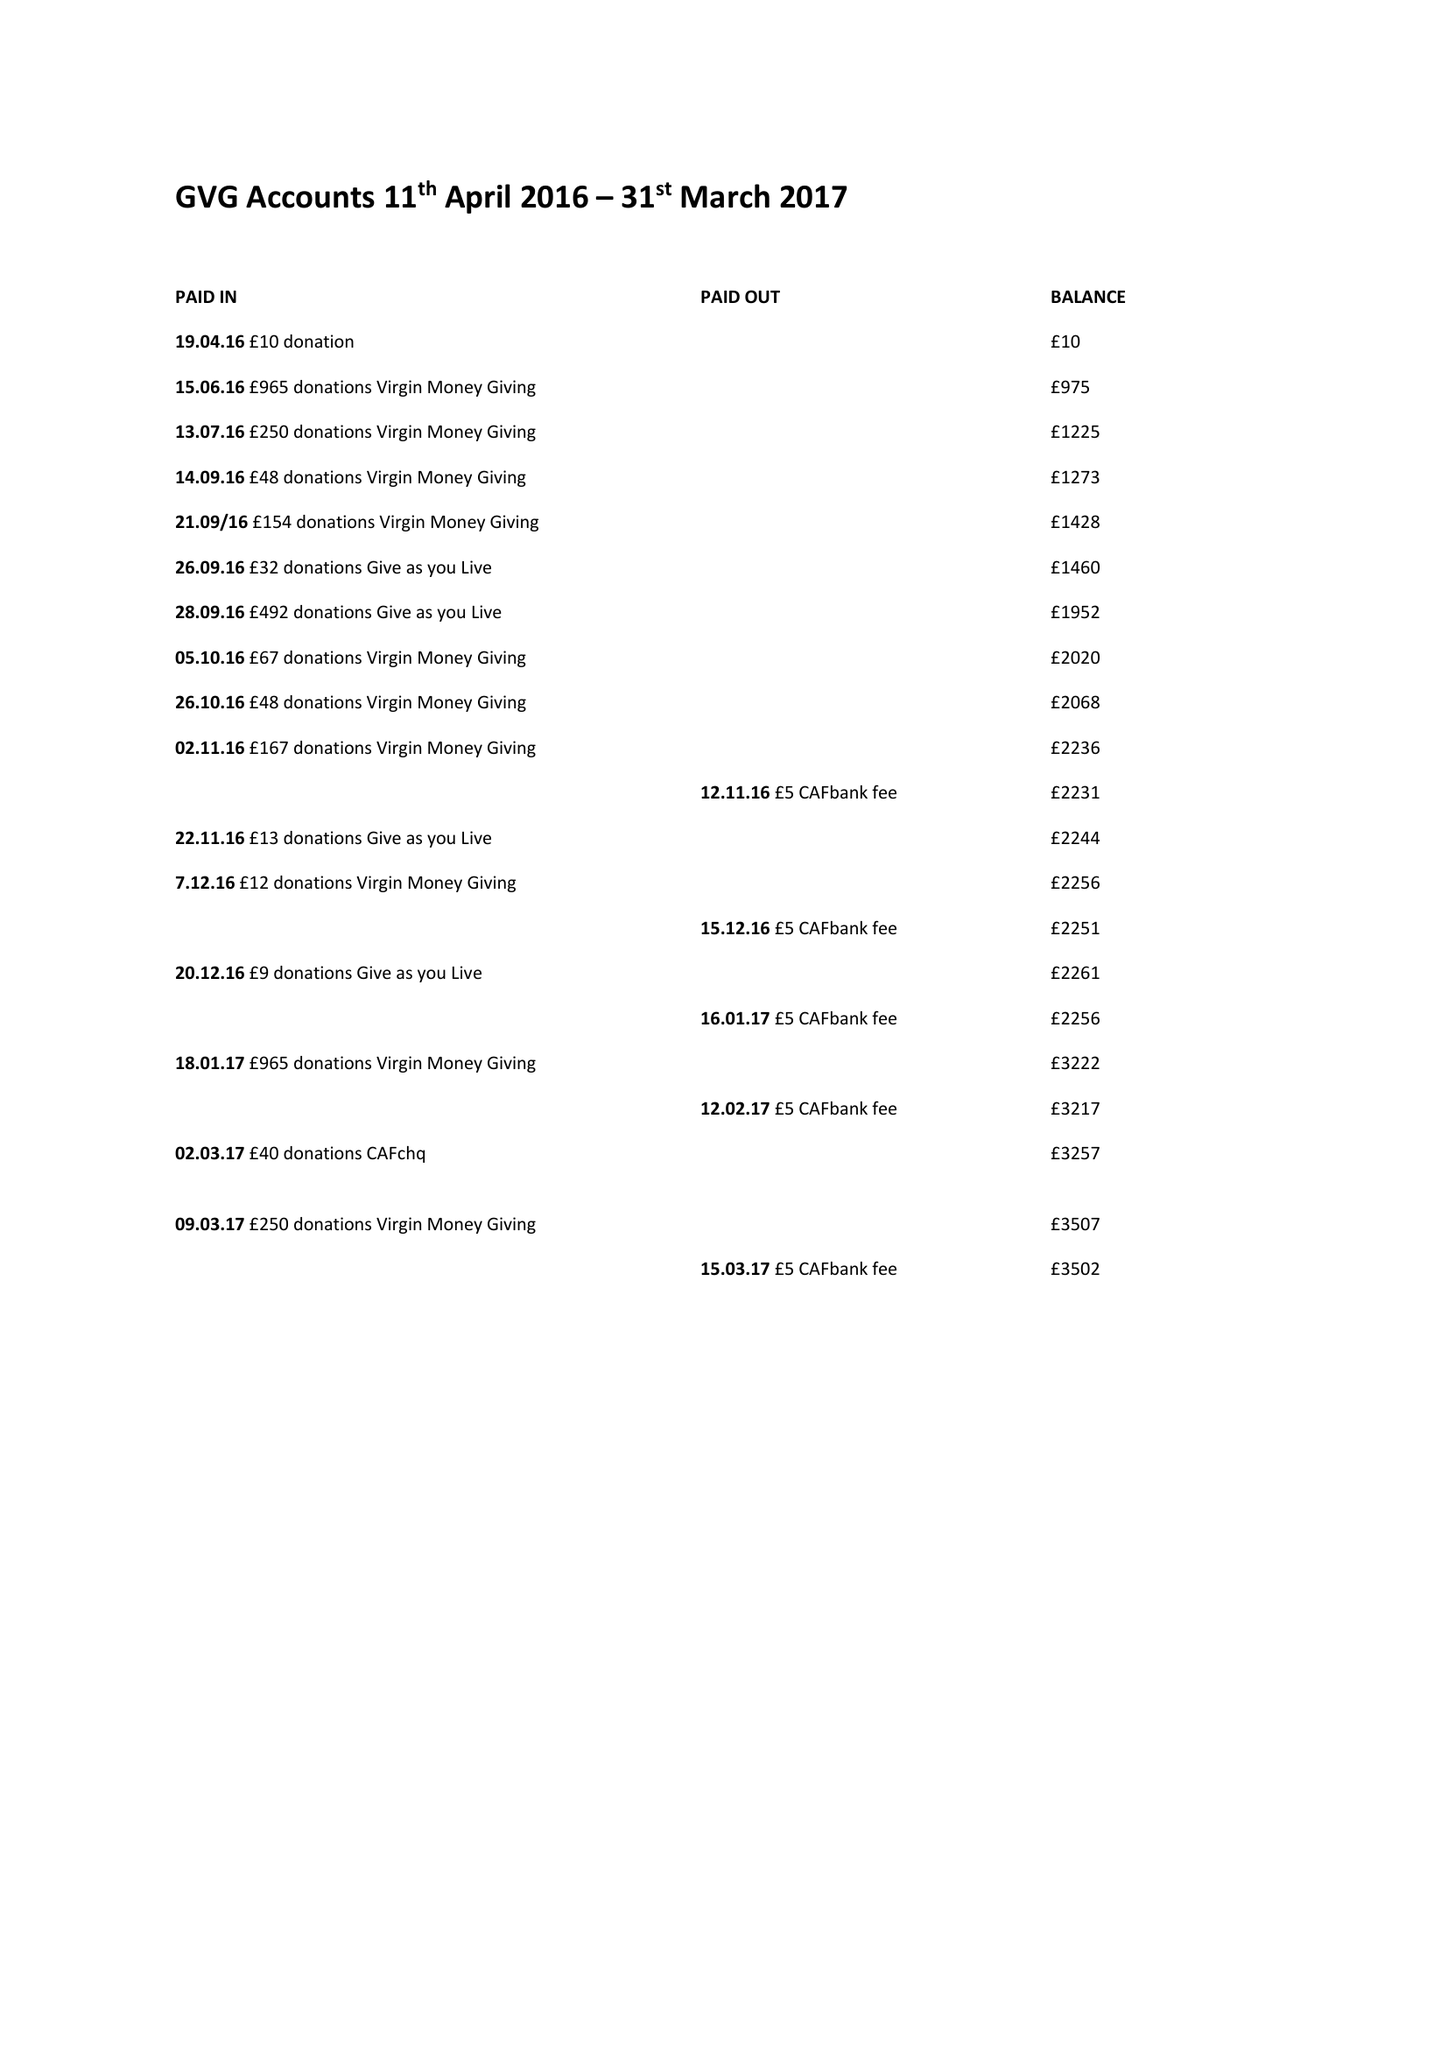What is the value for the address__post_town?
Answer the question using a single word or phrase. LONDON 